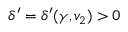Convert formula to latex. <formula><loc_0><loc_0><loc_500><loc_500>\delta ^ { \prime } = \delta ^ { \prime } ( \gamma , v _ { 2 } ) > 0</formula> 